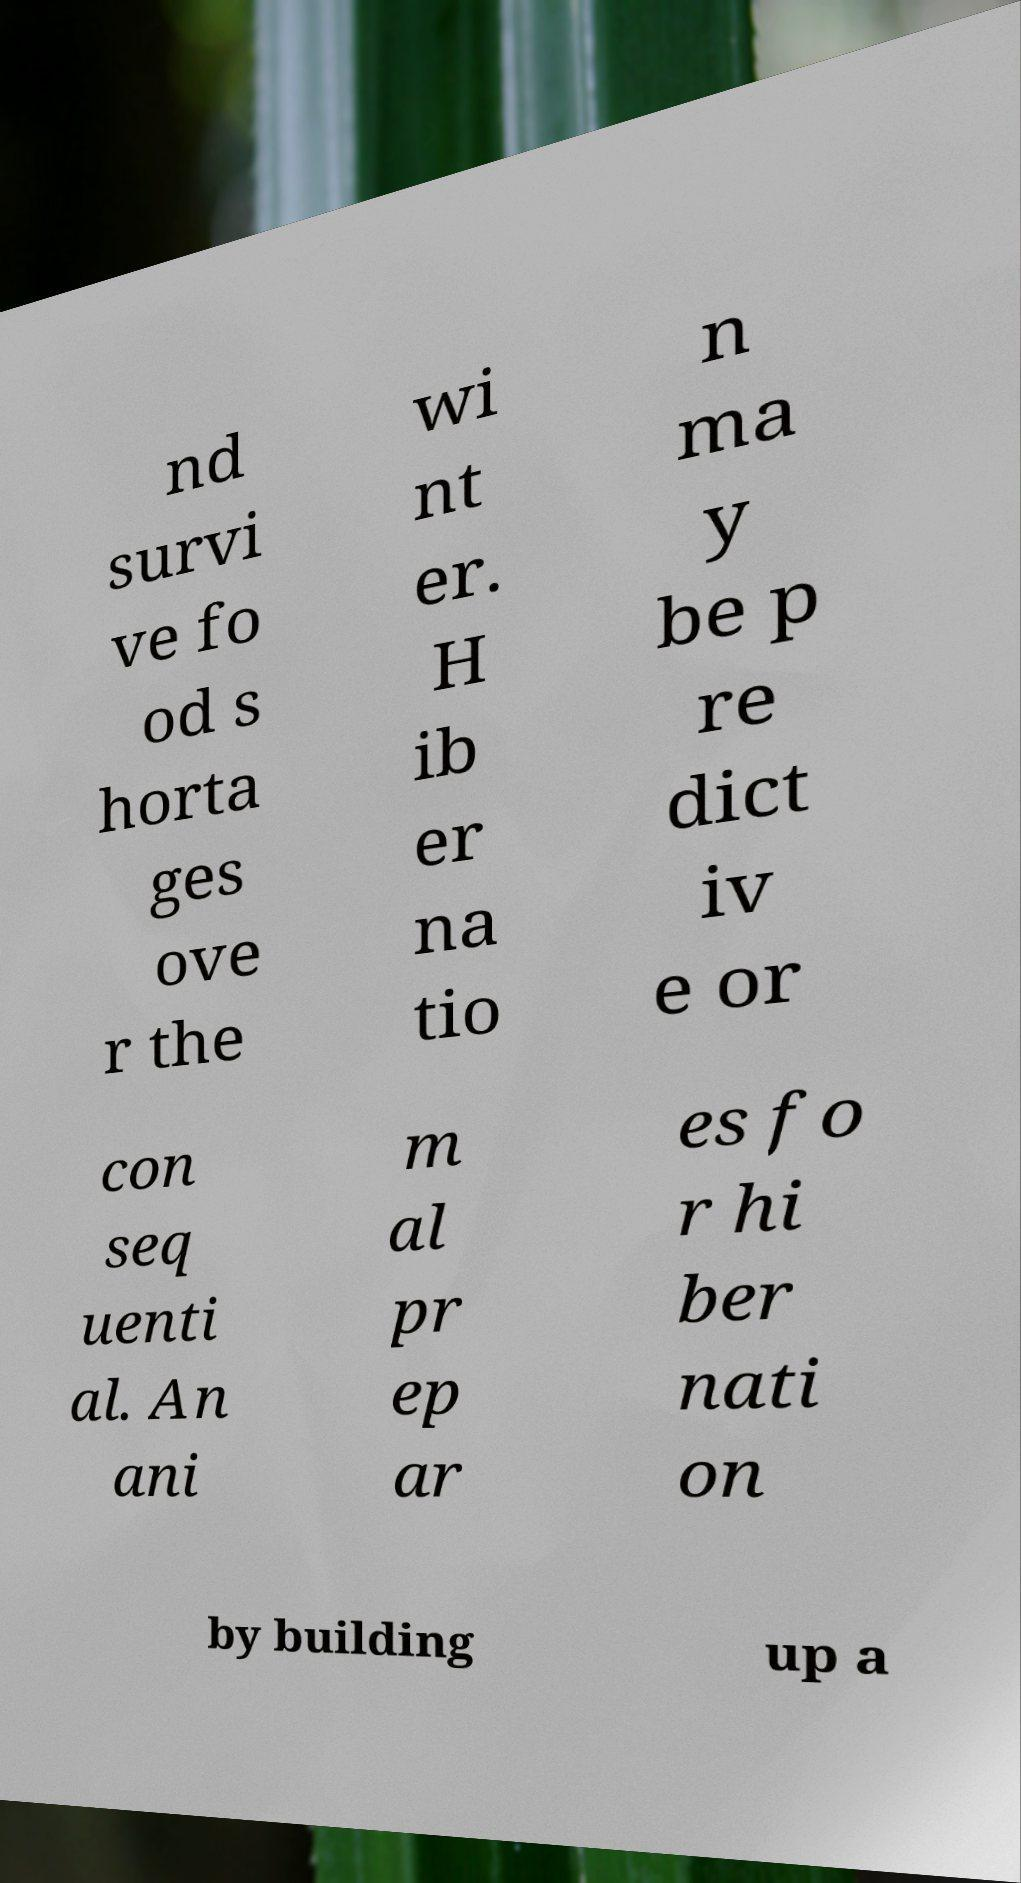Please identify and transcribe the text found in this image. nd survi ve fo od s horta ges ove r the wi nt er. H ib er na tio n ma y be p re dict iv e or con seq uenti al. An ani m al pr ep ar es fo r hi ber nati on by building up a 